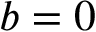<formula> <loc_0><loc_0><loc_500><loc_500>b = 0</formula> 